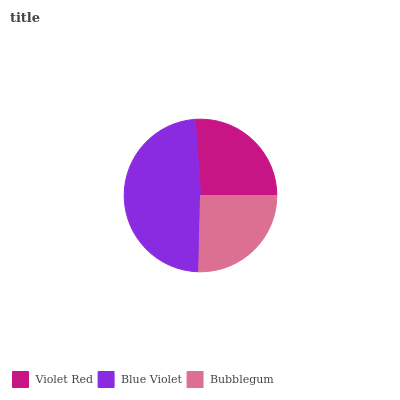Is Bubblegum the minimum?
Answer yes or no. Yes. Is Blue Violet the maximum?
Answer yes or no. Yes. Is Blue Violet the minimum?
Answer yes or no. No. Is Bubblegum the maximum?
Answer yes or no. No. Is Blue Violet greater than Bubblegum?
Answer yes or no. Yes. Is Bubblegum less than Blue Violet?
Answer yes or no. Yes. Is Bubblegum greater than Blue Violet?
Answer yes or no. No. Is Blue Violet less than Bubblegum?
Answer yes or no. No. Is Violet Red the high median?
Answer yes or no. Yes. Is Violet Red the low median?
Answer yes or no. Yes. Is Bubblegum the high median?
Answer yes or no. No. Is Bubblegum the low median?
Answer yes or no. No. 